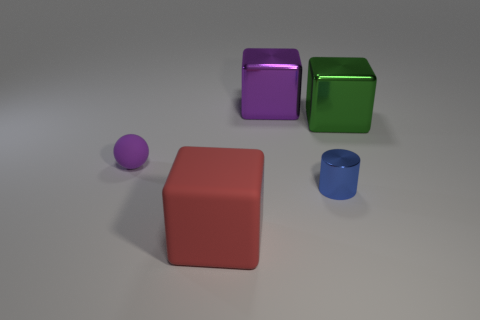Does the cube that is on the left side of the purple metallic thing have the same material as the object behind the big green shiny block?
Provide a short and direct response. No. Are there more blue shiny things to the left of the red matte object than small metal objects that are behind the purple ball?
Provide a succinct answer. No. What is the shape of the shiny object that is the same size as the green block?
Your response must be concise. Cube. How many things are brown rubber cubes or purple things that are to the right of the purple matte sphere?
Your answer should be compact. 1. Does the tiny sphere have the same color as the tiny metallic thing?
Offer a terse response. No. There is a small sphere; how many big green cubes are right of it?
Ensure brevity in your answer.  1. There is a big block that is the same material as the small purple sphere; what color is it?
Keep it short and to the point. Red. How many metallic things are either large green objects or cyan cubes?
Provide a succinct answer. 1. Does the red thing have the same material as the large green block?
Your answer should be compact. No. There is a big object that is to the left of the purple metallic thing; what is its shape?
Provide a short and direct response. Cube. 